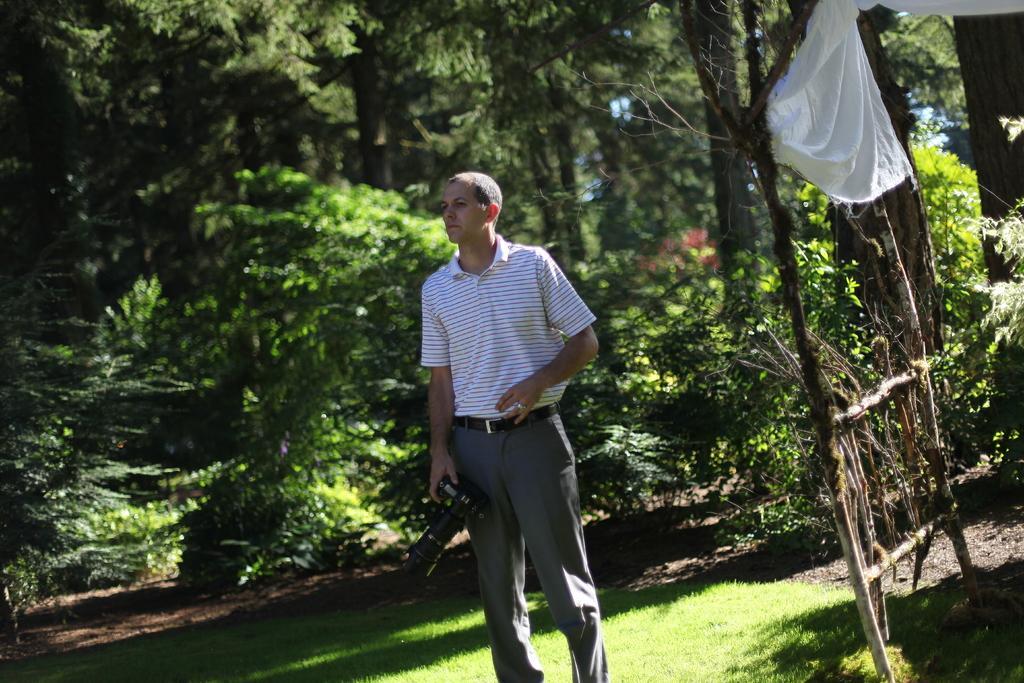How would you summarize this image in a sentence or two? In this image we can see a person standing on the grass holding a camera. On the right side we can see a cloth hanged to the branches of the tree. On the backside we can see some trees and the bark of the trees. 